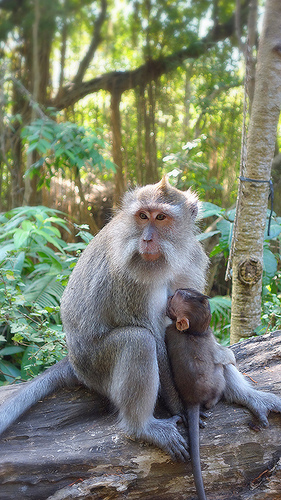<image>
Is the monkey behind the leaf? No. The monkey is not behind the leaf. From this viewpoint, the monkey appears to be positioned elsewhere in the scene. Is the monkey under the tree? Yes. The monkey is positioned underneath the tree, with the tree above it in the vertical space. 